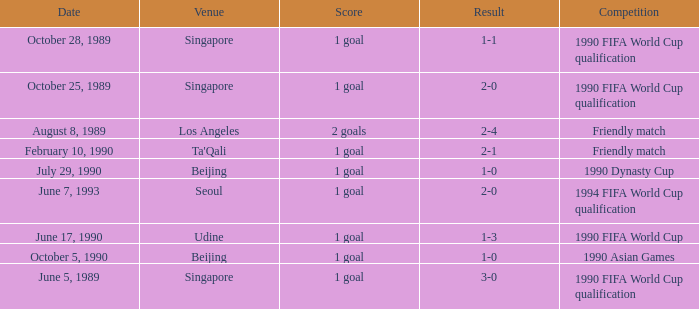What is the score of the match on October 5, 1990? 1 goal. 